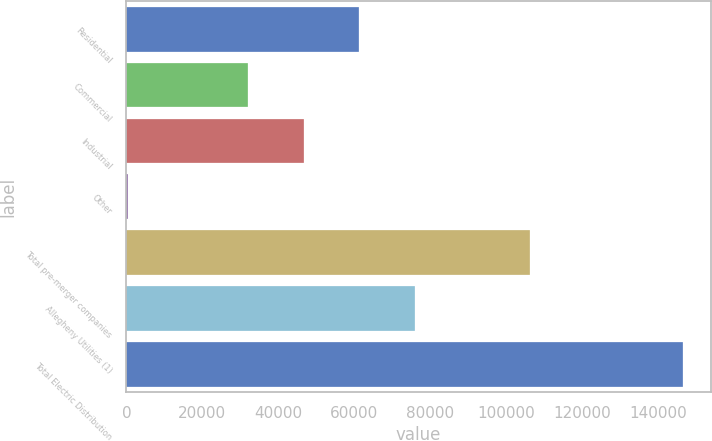Convert chart. <chart><loc_0><loc_0><loc_500><loc_500><bar_chart><fcel>Residential<fcel>Commercial<fcel>Industrial<fcel>Other<fcel>Total pre-merger companies<fcel>Allegheny Utilities (1)<fcel>Total Electric Distribution<nl><fcel>61370.8<fcel>32149<fcel>46759.9<fcel>492<fcel>106273<fcel>75981.7<fcel>146601<nl></chart> 